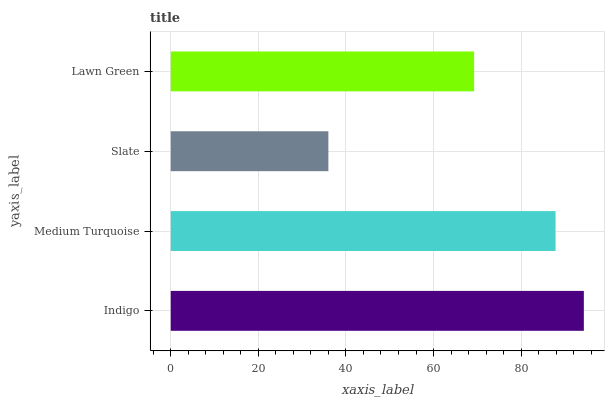Is Slate the minimum?
Answer yes or no. Yes. Is Indigo the maximum?
Answer yes or no. Yes. Is Medium Turquoise the minimum?
Answer yes or no. No. Is Medium Turquoise the maximum?
Answer yes or no. No. Is Indigo greater than Medium Turquoise?
Answer yes or no. Yes. Is Medium Turquoise less than Indigo?
Answer yes or no. Yes. Is Medium Turquoise greater than Indigo?
Answer yes or no. No. Is Indigo less than Medium Turquoise?
Answer yes or no. No. Is Medium Turquoise the high median?
Answer yes or no. Yes. Is Lawn Green the low median?
Answer yes or no. Yes. Is Lawn Green the high median?
Answer yes or no. No. Is Medium Turquoise the low median?
Answer yes or no. No. 